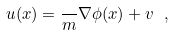Convert formula to latex. <formula><loc_0><loc_0><loc_500><loc_500>u ( x ) = \frac { } { m } \nabla \phi ( x ) + v \ ,</formula> 